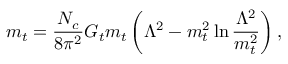<formula> <loc_0><loc_0><loc_500><loc_500>m _ { t } = \frac { N _ { c } } { 8 \pi ^ { 2 } } G _ { t } m _ { t } \left ( \Lambda ^ { 2 } - m _ { t } ^ { 2 } \ln \frac { \Lambda ^ { 2 } } { m _ { t } ^ { 2 } } \right ) ,</formula> 